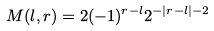<formula> <loc_0><loc_0><loc_500><loc_500>M ( l , r ) = 2 ( - 1 ) ^ { r - l } 2 ^ { - | r - l | - 2 }</formula> 